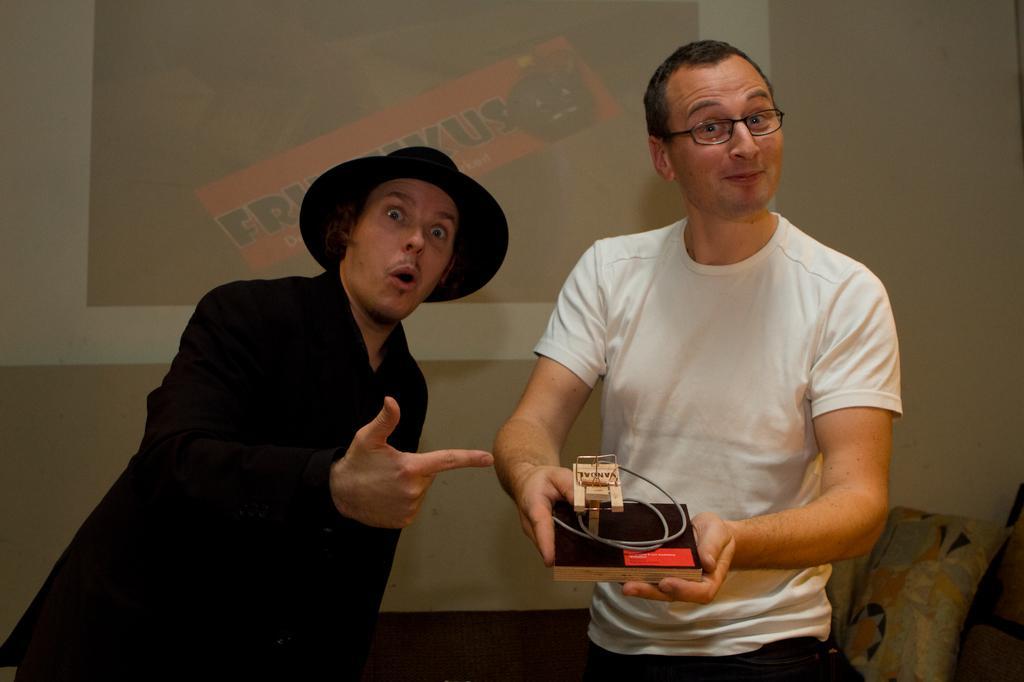How would you summarize this image in a sentence or two? In this picture we can see two men standing here, a man on the right side is holding something, a man on the left side wore a cap, in the background there is projector screen, we can see a pillow here, there is a wall here. 